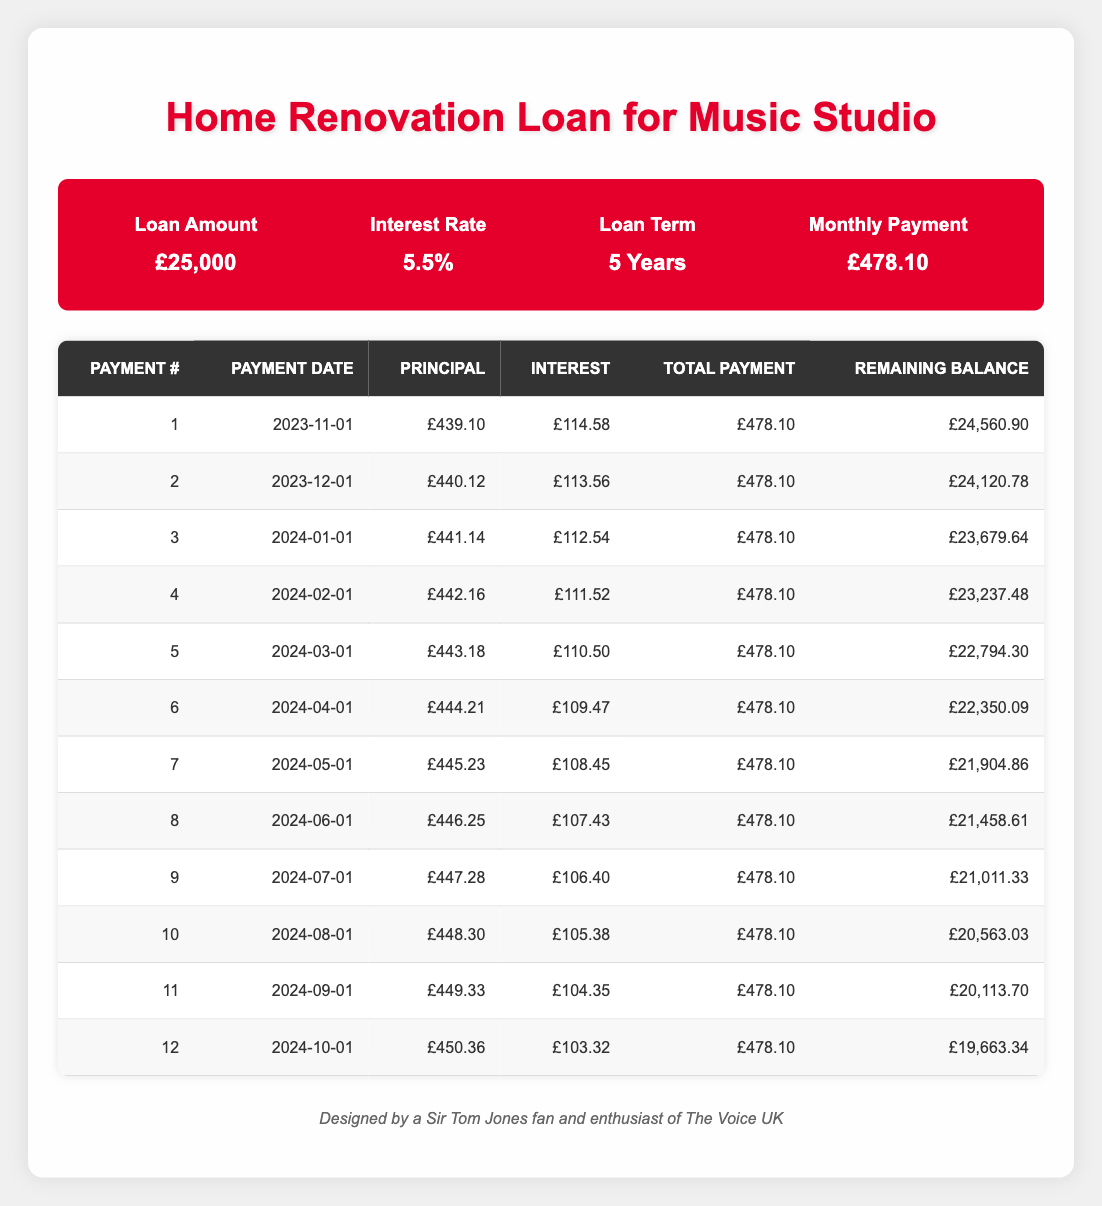What is the total payment made in the first month? The total payment for the first month can be found directly in the first row of the table under the 'Total Payment' column. It is listed as £478.10.
Answer: £478.10 What is the principal payment for the second month? The principal payment for the second month is provided directly in the second row of the table, under the 'Principal' column, which is £440.12.
Answer: £440.12 How much interest is paid in the first 3 months combined? To find the total interest paid in the first 3 months, sum the interest payments for these months: £114.58 + £113.56 + £112.54 = £340.68.
Answer: £340.68 What will be the remaining balance after the 5th payment? The remaining balance after the 5th payment is found in the table under the 'Remaining Balance' column for the 5th payment, which is £22,794.30.
Answer: £22,794.30 True or False: The interest payment for the 11th month is higher than the interest payment for the 12th month. To determine this, compare the interest payments in the 11th and 12th rows. The interest for the 11th month is £104.35 and for the 12th month is £103.32. Since £104.35 is greater than £103.32, the statement is true.
Answer: True What is the average principal payment made in the first year (12 months)? The total principal payments for the first 12 months can be calculated by summing each of the principal payments from the table, which is £439.10 + £440.12 + £441.14 + £442.16 + £443.18 + £444.21 + £445.23 + £446.25 + £447.28 + £448.30 + £449.33 + £450.36 = £5,327.74. Then, divide this sum by the number of payments (12): £5,327.74 / 12 = £444.81.
Answer: £444.81 What is the difference between the first and last payment amounts? The first payment consists of a principal portion of £439.10, and the last payment (12th month) has a principal portion of £450.36. To find the difference, subtract the first month's principal from the twelfth month's principal: £450.36 - £439.10 = £11.26.
Answer: £11.26 How much did the remaining balance decrease in the first three months? To find this, look at the remaining balances at the start and end of the first three months. The remaining balance after the 1st month is £24,560.90 and after the 3rd month it is £23,679.64. The decrease in balance is calculated as £24,560.90 - £23,679.64 = £881.26.
Answer: £881.26 Are the total payments the same for each month throughout the loan? All rows under the 'Total Payment' column show that the payment amount is consistently £478.10 for each month, indicating that yes, the total payments are the same.
Answer: Yes 